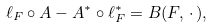Convert formula to latex. <formula><loc_0><loc_0><loc_500><loc_500>\ell _ { F } \circ A - A ^ { * } \circ \ell _ { F } ^ { * } = B ( F , \, \cdot \, ) ,</formula> 